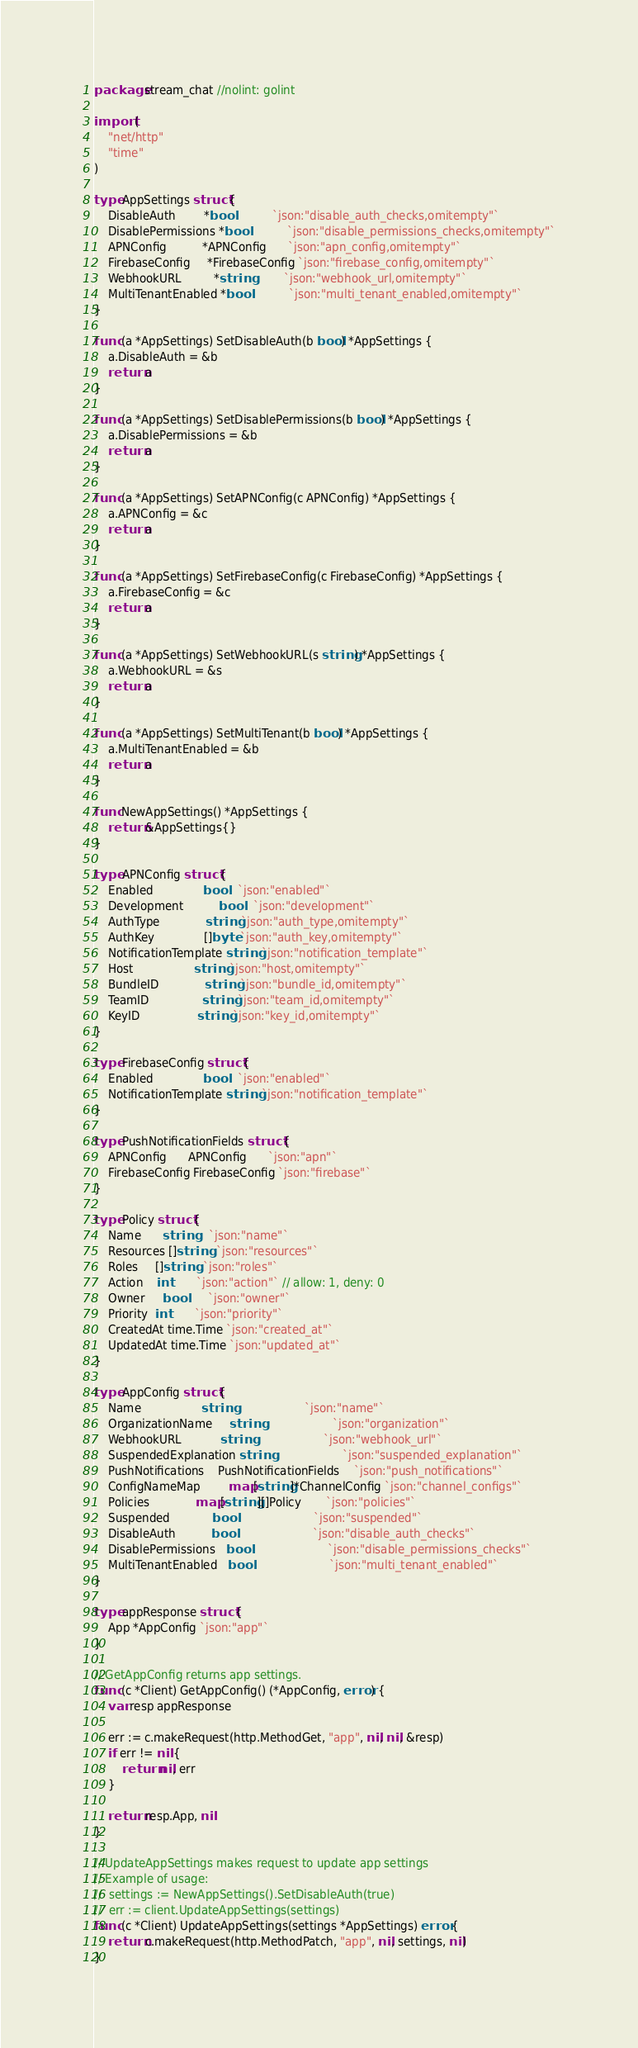Convert code to text. <code><loc_0><loc_0><loc_500><loc_500><_Go_>package stream_chat //nolint: golint

import (
	"net/http"
	"time"
)

type AppSettings struct {
	DisableAuth        *bool           `json:"disable_auth_checks,omitempty"`
	DisablePermissions *bool           `json:"disable_permissions_checks,omitempty"`
	APNConfig          *APNConfig      `json:"apn_config,omitempty"`
	FirebaseConfig     *FirebaseConfig `json:"firebase_config,omitempty"`
	WebhookURL         *string         `json:"webhook_url,omitempty"`
	MultiTenantEnabled *bool           `json:"multi_tenant_enabled,omitempty"`
}

func (a *AppSettings) SetDisableAuth(b bool) *AppSettings {
	a.DisableAuth = &b
	return a
}

func (a *AppSettings) SetDisablePermissions(b bool) *AppSettings {
	a.DisablePermissions = &b
	return a
}

func (a *AppSettings) SetAPNConfig(c APNConfig) *AppSettings {
	a.APNConfig = &c
	return a
}

func (a *AppSettings) SetFirebaseConfig(c FirebaseConfig) *AppSettings {
	a.FirebaseConfig = &c
	return a
}

func (a *AppSettings) SetWebhookURL(s string) *AppSettings {
	a.WebhookURL = &s
	return a
}

func (a *AppSettings) SetMultiTenant(b bool) *AppSettings {
	a.MultiTenantEnabled = &b
	return a
}

func NewAppSettings() *AppSettings {
	return &AppSettings{}
}

type APNConfig struct {
	Enabled              bool   `json:"enabled"`
	Development          bool   `json:"development"`
	AuthType             string `json:"auth_type,omitempty"`
	AuthKey              []byte `json:"auth_key,omitempty"`
	NotificationTemplate string `json:"notification_template"`
	Host                 string `json:"host,omitempty"`
	BundleID             string `json:"bundle_id,omitempty"`
	TeamID               string `json:"team_id,omitempty"`
	KeyID                string `json:"key_id,omitempty"`
}

type FirebaseConfig struct {
	Enabled              bool   `json:"enabled"`
	NotificationTemplate string `json:"notification_template"`
}

type PushNotificationFields struct {
	APNConfig      APNConfig      `json:"apn"`
	FirebaseConfig FirebaseConfig `json:"firebase"`
}

type Policy struct {
	Name      string    `json:"name"`
	Resources []string  `json:"resources"`
	Roles     []string  `json:"roles"`
	Action    int       `json:"action"` // allow: 1, deny: 0
	Owner     bool      `json:"owner"`
	Priority  int       `json:"priority"`
	CreatedAt time.Time `json:"created_at"`
	UpdatedAt time.Time `json:"updated_at"`
}

type AppConfig struct {
	Name                 string                    `json:"name"`
	OrganizationName     string                    `json:"organization"`
	WebhookURL           string                    `json:"webhook_url"`
	SuspendedExplanation string                    `json:"suspended_explanation"`
	PushNotifications    PushNotificationFields    `json:"push_notifications"`
	ConfigNameMap        map[string]*ChannelConfig `json:"channel_configs"`
	Policies             map[string][]Policy       `json:"policies"`
	Suspended            bool                      `json:"suspended"`
	DisableAuth          bool                      `json:"disable_auth_checks"`
	DisablePermissions   bool                      `json:"disable_permissions_checks"`
	MultiTenantEnabled   bool                      `json:"multi_tenant_enabled"`
}

type appResponse struct {
	App *AppConfig `json:"app"`
}

// GetAppConfig returns app settings.
func (c *Client) GetAppConfig() (*AppConfig, error) {
	var resp appResponse

	err := c.makeRequest(http.MethodGet, "app", nil, nil, &resp)
	if err != nil {
		return nil, err
	}

	return resp.App, nil
}

// UpdateAppSettings makes request to update app settings
// Example of usage:
//  settings := NewAppSettings().SetDisableAuth(true)
//  err := client.UpdateAppSettings(settings)
func (c *Client) UpdateAppSettings(settings *AppSettings) error {
	return c.makeRequest(http.MethodPatch, "app", nil, settings, nil)
}
</code> 